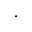Convert formula to latex. <formula><loc_0><loc_0><loc_500><loc_500>\cdot</formula> 